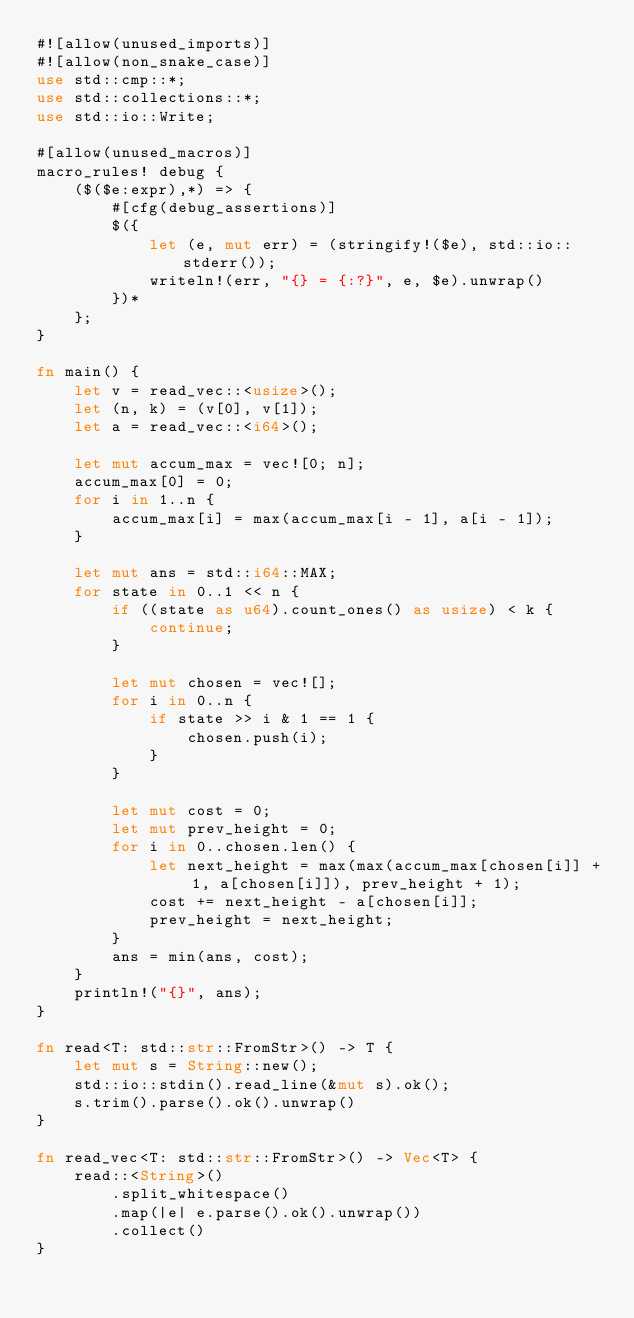Convert code to text. <code><loc_0><loc_0><loc_500><loc_500><_Rust_>#![allow(unused_imports)]
#![allow(non_snake_case)]
use std::cmp::*;
use std::collections::*;
use std::io::Write;

#[allow(unused_macros)]
macro_rules! debug {
    ($($e:expr),*) => {
        #[cfg(debug_assertions)]
        $({
            let (e, mut err) = (stringify!($e), std::io::stderr());
            writeln!(err, "{} = {:?}", e, $e).unwrap()
        })*
    };
}

fn main() {
    let v = read_vec::<usize>();
    let (n, k) = (v[0], v[1]);
    let a = read_vec::<i64>();

    let mut accum_max = vec![0; n];
    accum_max[0] = 0;
    for i in 1..n {
        accum_max[i] = max(accum_max[i - 1], a[i - 1]);
    }

    let mut ans = std::i64::MAX;
    for state in 0..1 << n {
        if ((state as u64).count_ones() as usize) < k {
            continue;
        }

        let mut chosen = vec![];
        for i in 0..n {
            if state >> i & 1 == 1 {
                chosen.push(i);
            }
        }

        let mut cost = 0;
        let mut prev_height = 0;
        for i in 0..chosen.len() {
            let next_height = max(max(accum_max[chosen[i]] + 1, a[chosen[i]]), prev_height + 1);
            cost += next_height - a[chosen[i]];
            prev_height = next_height;
        }
        ans = min(ans, cost);
    }
    println!("{}", ans);
}

fn read<T: std::str::FromStr>() -> T {
    let mut s = String::new();
    std::io::stdin().read_line(&mut s).ok();
    s.trim().parse().ok().unwrap()
}

fn read_vec<T: std::str::FromStr>() -> Vec<T> {
    read::<String>()
        .split_whitespace()
        .map(|e| e.parse().ok().unwrap())
        .collect()
}
</code> 